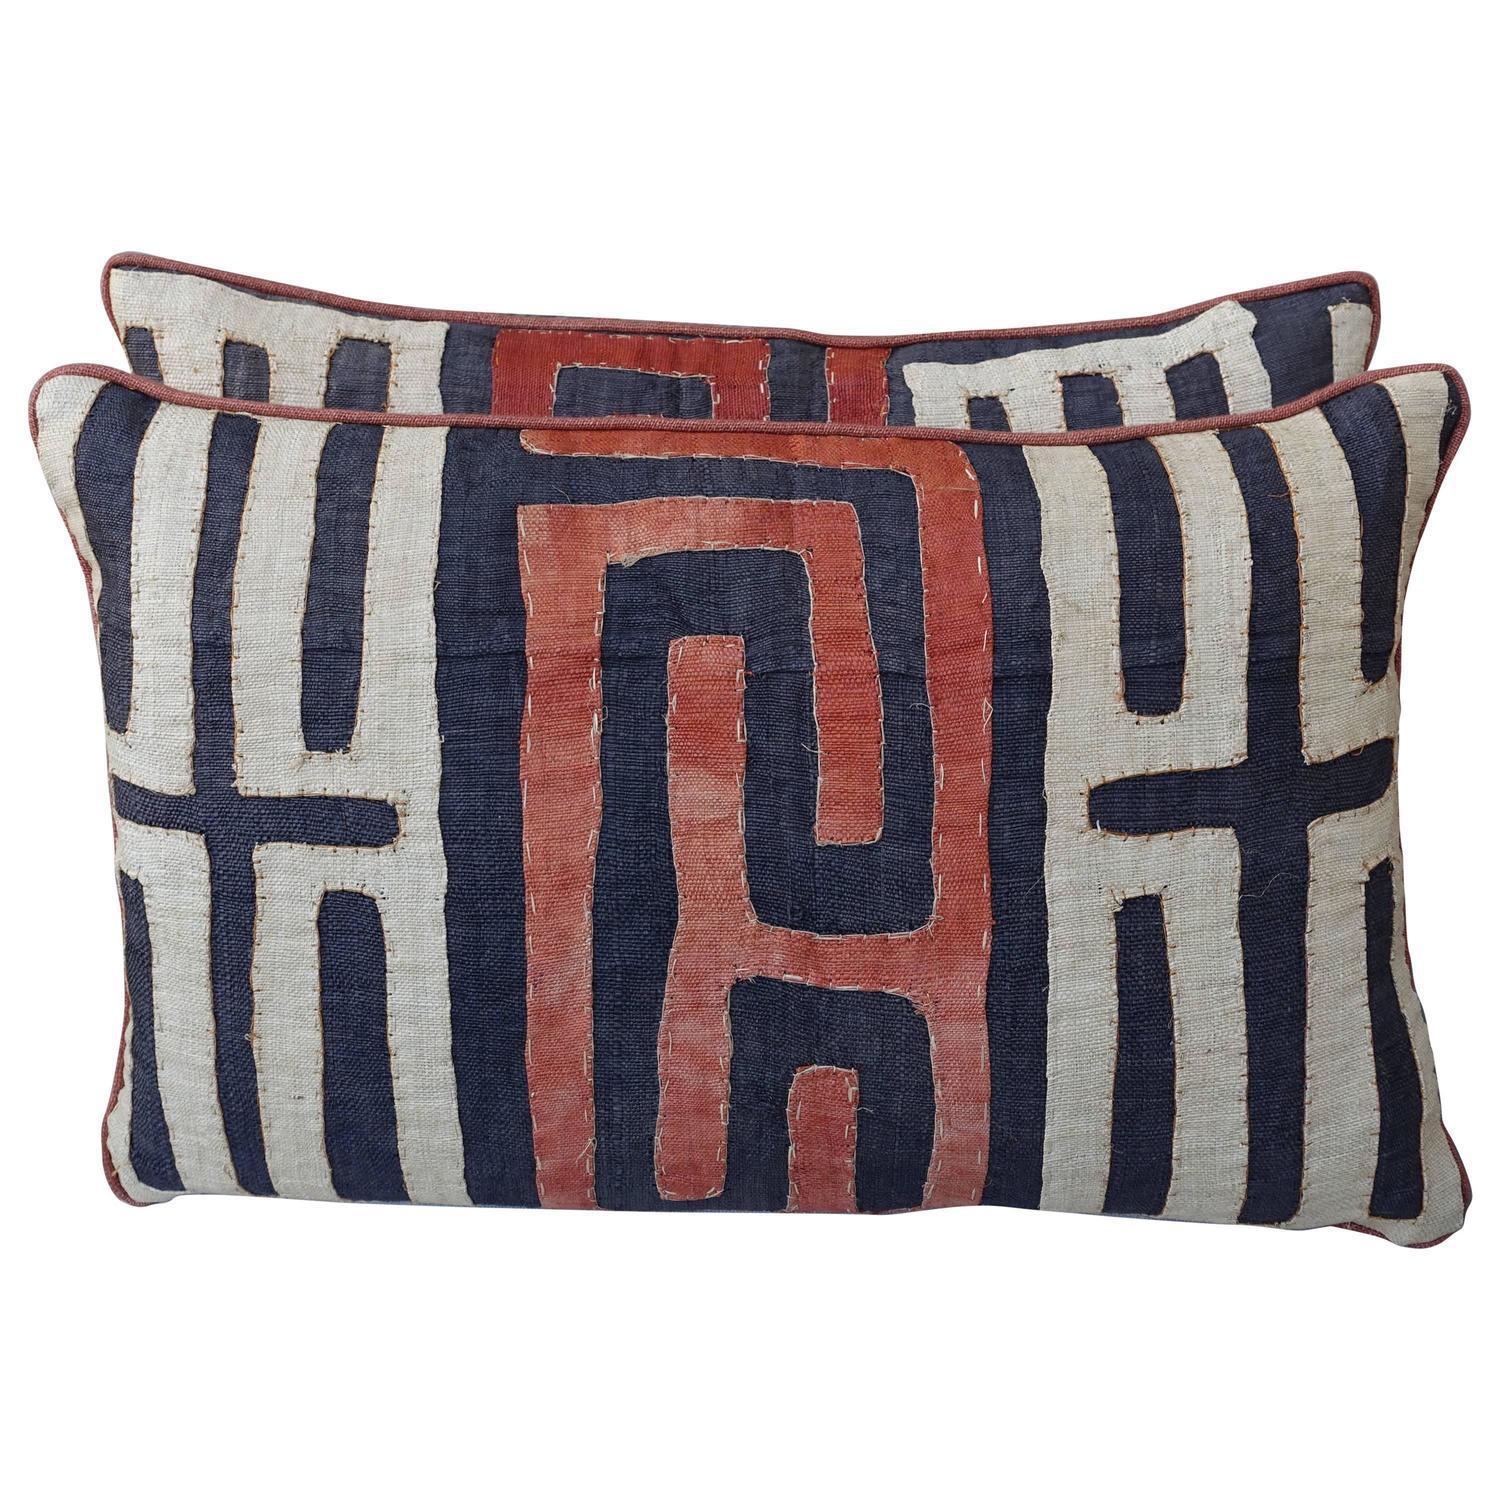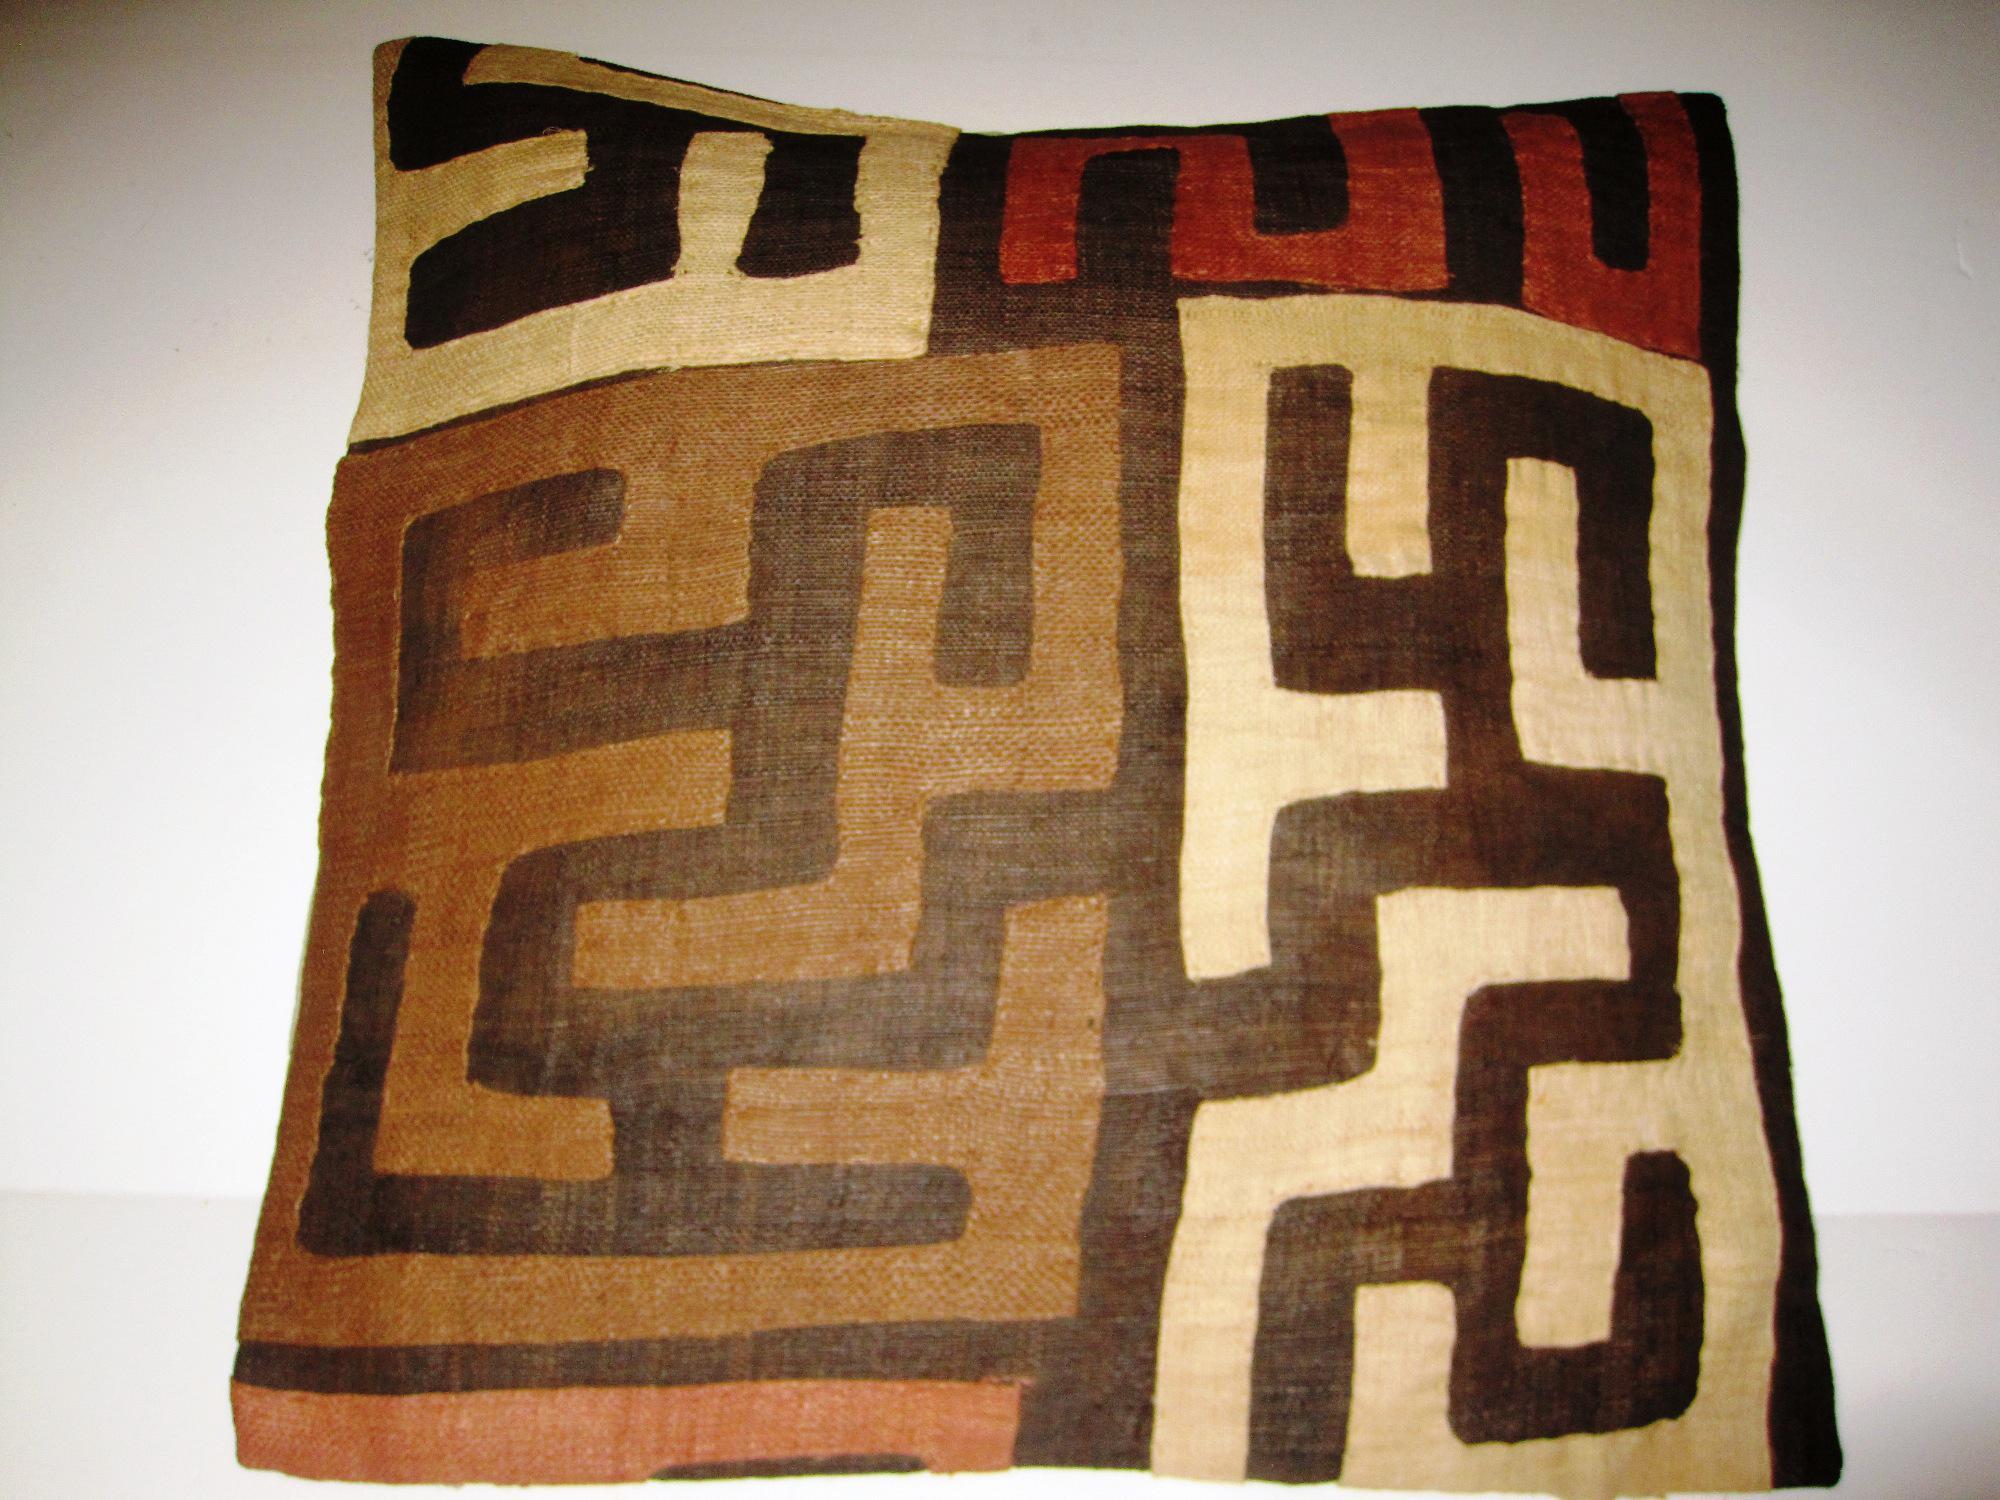The first image is the image on the left, the second image is the image on the right. Analyze the images presented: Is the assertion "There are no more than two pillows in each image." valid? Answer yes or no. Yes. 